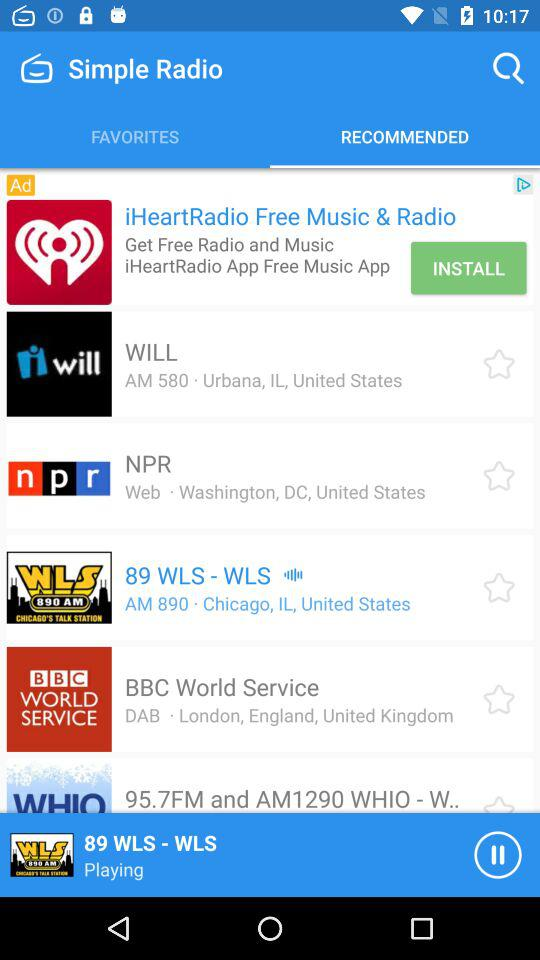What is the location of NPR? The location of NPR is Washington, DC, United States. 